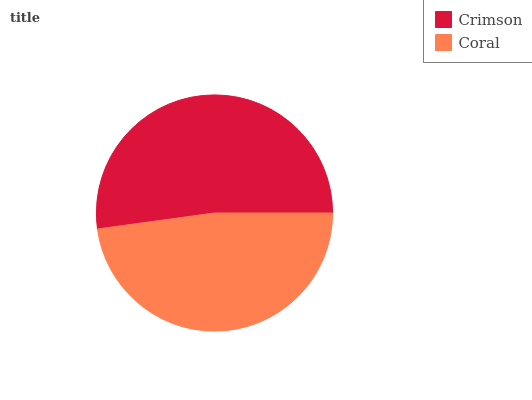Is Coral the minimum?
Answer yes or no. Yes. Is Crimson the maximum?
Answer yes or no. Yes. Is Coral the maximum?
Answer yes or no. No. Is Crimson greater than Coral?
Answer yes or no. Yes. Is Coral less than Crimson?
Answer yes or no. Yes. Is Coral greater than Crimson?
Answer yes or no. No. Is Crimson less than Coral?
Answer yes or no. No. Is Crimson the high median?
Answer yes or no. Yes. Is Coral the low median?
Answer yes or no. Yes. Is Coral the high median?
Answer yes or no. No. Is Crimson the low median?
Answer yes or no. No. 